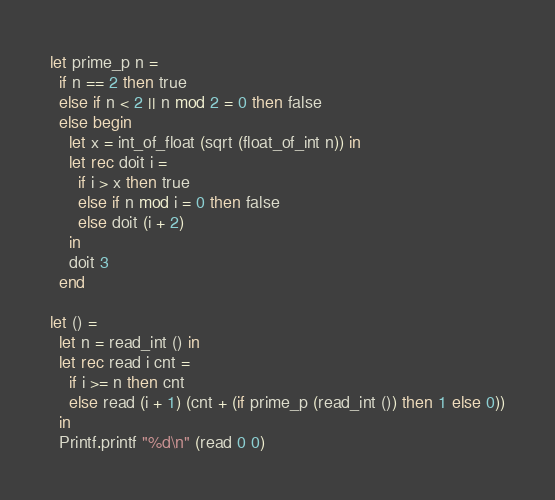<code> <loc_0><loc_0><loc_500><loc_500><_OCaml_>let prime_p n =
  if n == 2 then true
  else if n < 2 || n mod 2 = 0 then false
  else begin
    let x = int_of_float (sqrt (float_of_int n)) in
    let rec doit i =
      if i > x then true
      else if n mod i = 0 then false
      else doit (i + 2)
    in
    doit 3
  end

let () =
  let n = read_int () in
  let rec read i cnt =
    if i >= n then cnt
    else read (i + 1) (cnt + (if prime_p (read_int ()) then 1 else 0))
  in
  Printf.printf "%d\n" (read 0 0)</code> 